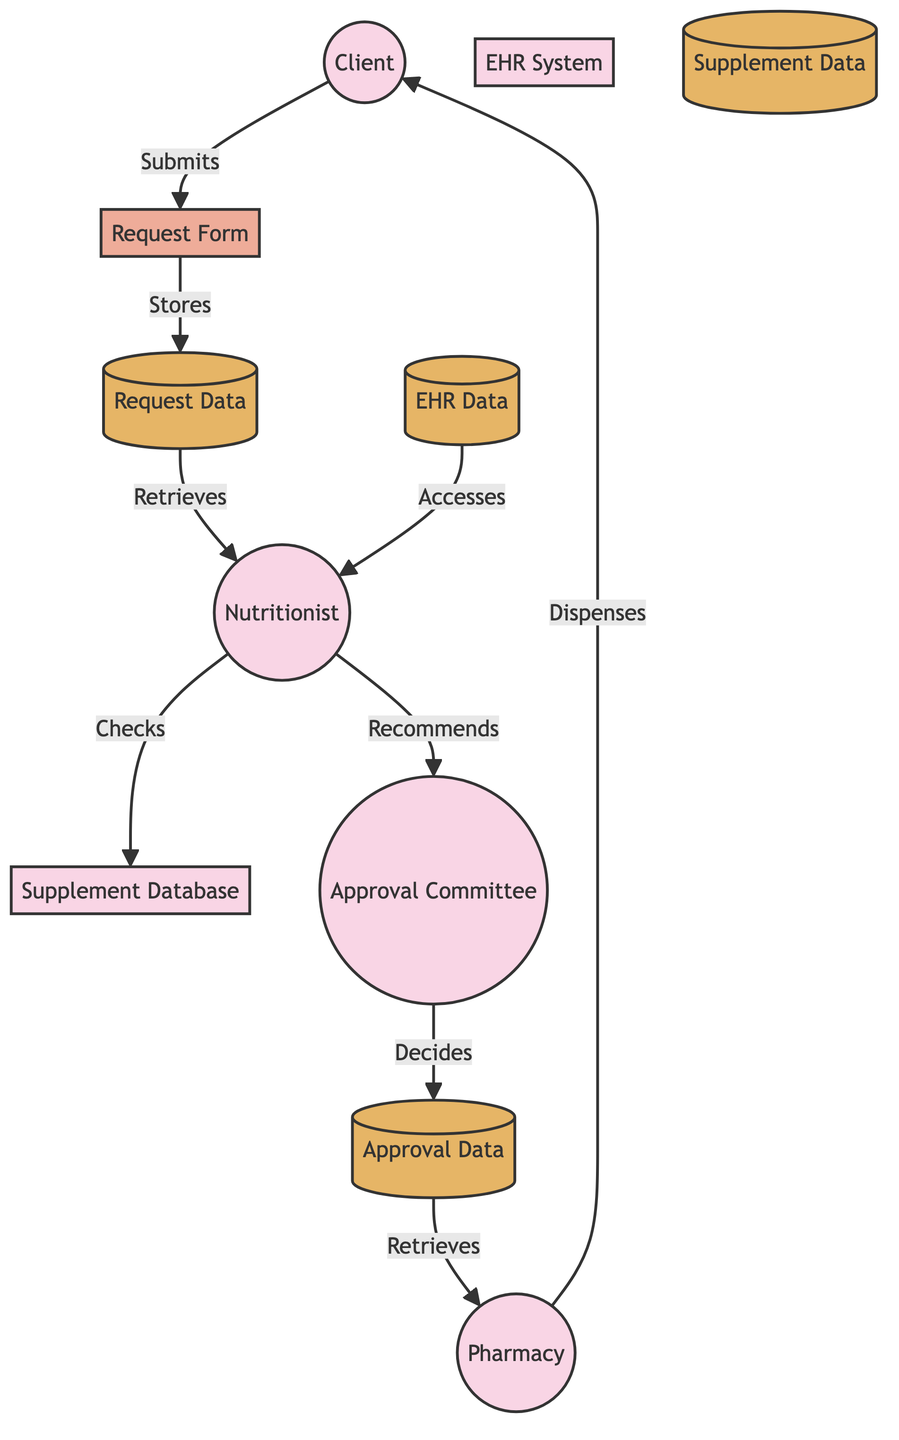What is the first step in the workflow? The first step in the workflow is the submission of the request form by the client, as indicated by the arrow leading from the client to the request form.
Answer: Request Submission How many main entities are present in the diagram? By counting the entities listed in the diagram, there are a total of seven main entities: Client, Nutritionist, Request Form, EHR System, Dietary Supplement Database, Approval Committee, and Pharmacy.
Answer: Seven What does the nutritionist access to carry out a health assessment? The nutritionist accesses the Electronic Health Record (EHR) data to review the client's health status and needs for dietary supplements.
Answer: EHR Data Which process does the nutritionist submit a recommendation to? The nutritionist submits the supplement recommendation to the Approval Committee, as indicated by the flow from the nutritionist to the approval committee.
Answer: Approval Review Where is the approval decision stored? The approval decision is stored in the Approval Data store, as shown by the flow from the approval committee to the approval data.
Answer: Approval Data How are approved dietary supplements dispensed to the client? The pharmacy dispenses approved dietary supplements to the client, as indicated by the flow moving from the pharmacy to the client.
Answer: Dispensation What data does the request form data get stored into? The data from the request form is stored into the Request Data store, per the flow indicated in the diagram.
Answer: Request Data Which entity is responsible for reviewing and approving supplement requests? The Approval Committee is responsible for reviewing and approving dietary supplement requests, as designated by the role outlined in the diagram.
Answer: Approval Committee What comes after the health assessment process? After the health assessment, the next process is the supplement recommendation, where the nutritionist makes a specific recommendation based on the health assessment.
Answer: Supplement Recommendation How does the pharmacy know which requests to fulfill? The pharmacy retrieves the approved supplement requests from the Approval Data store, as indicated by the flow from approval data to pharmacy.
Answer: Approval Data 